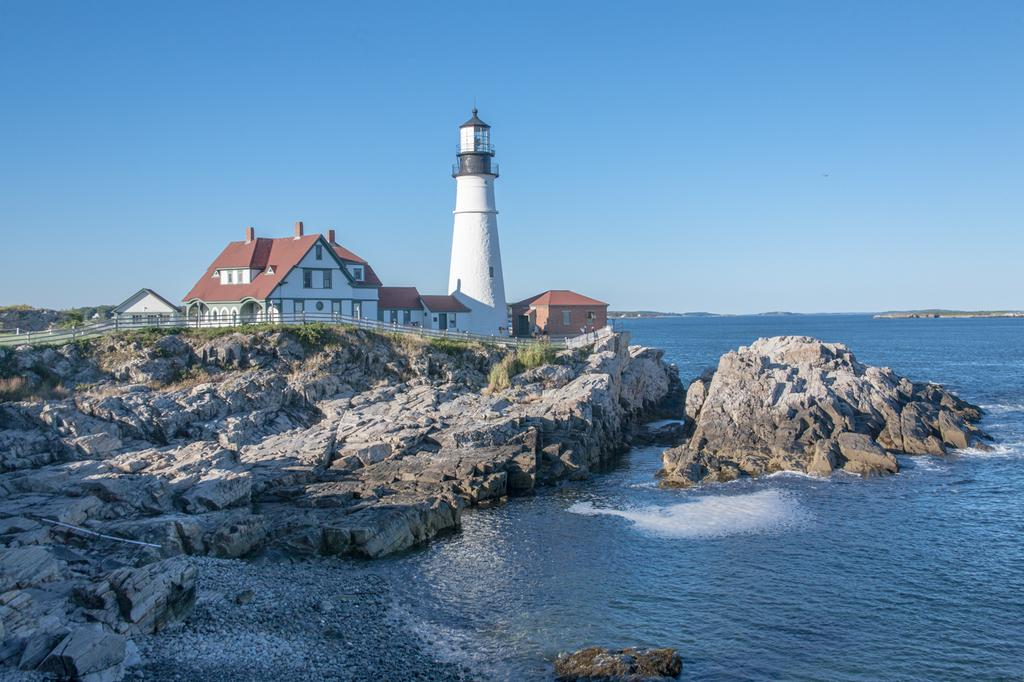What type of structure is located on the mountain in the image? There is a house on the mountain on the left side of the image. What natural feature is visible on the left side of the image? There is a sea on the left side of the image. What is visible at the top of the image? The sky is visible at the top of the image. How many books are stacked on the skate in the image? There are no books or skates present in the image. What impulse might have led to the creation of the house on the mountain in the image? The image does not provide information about the reasons or motivations behind the construction of the house on the mountain. 